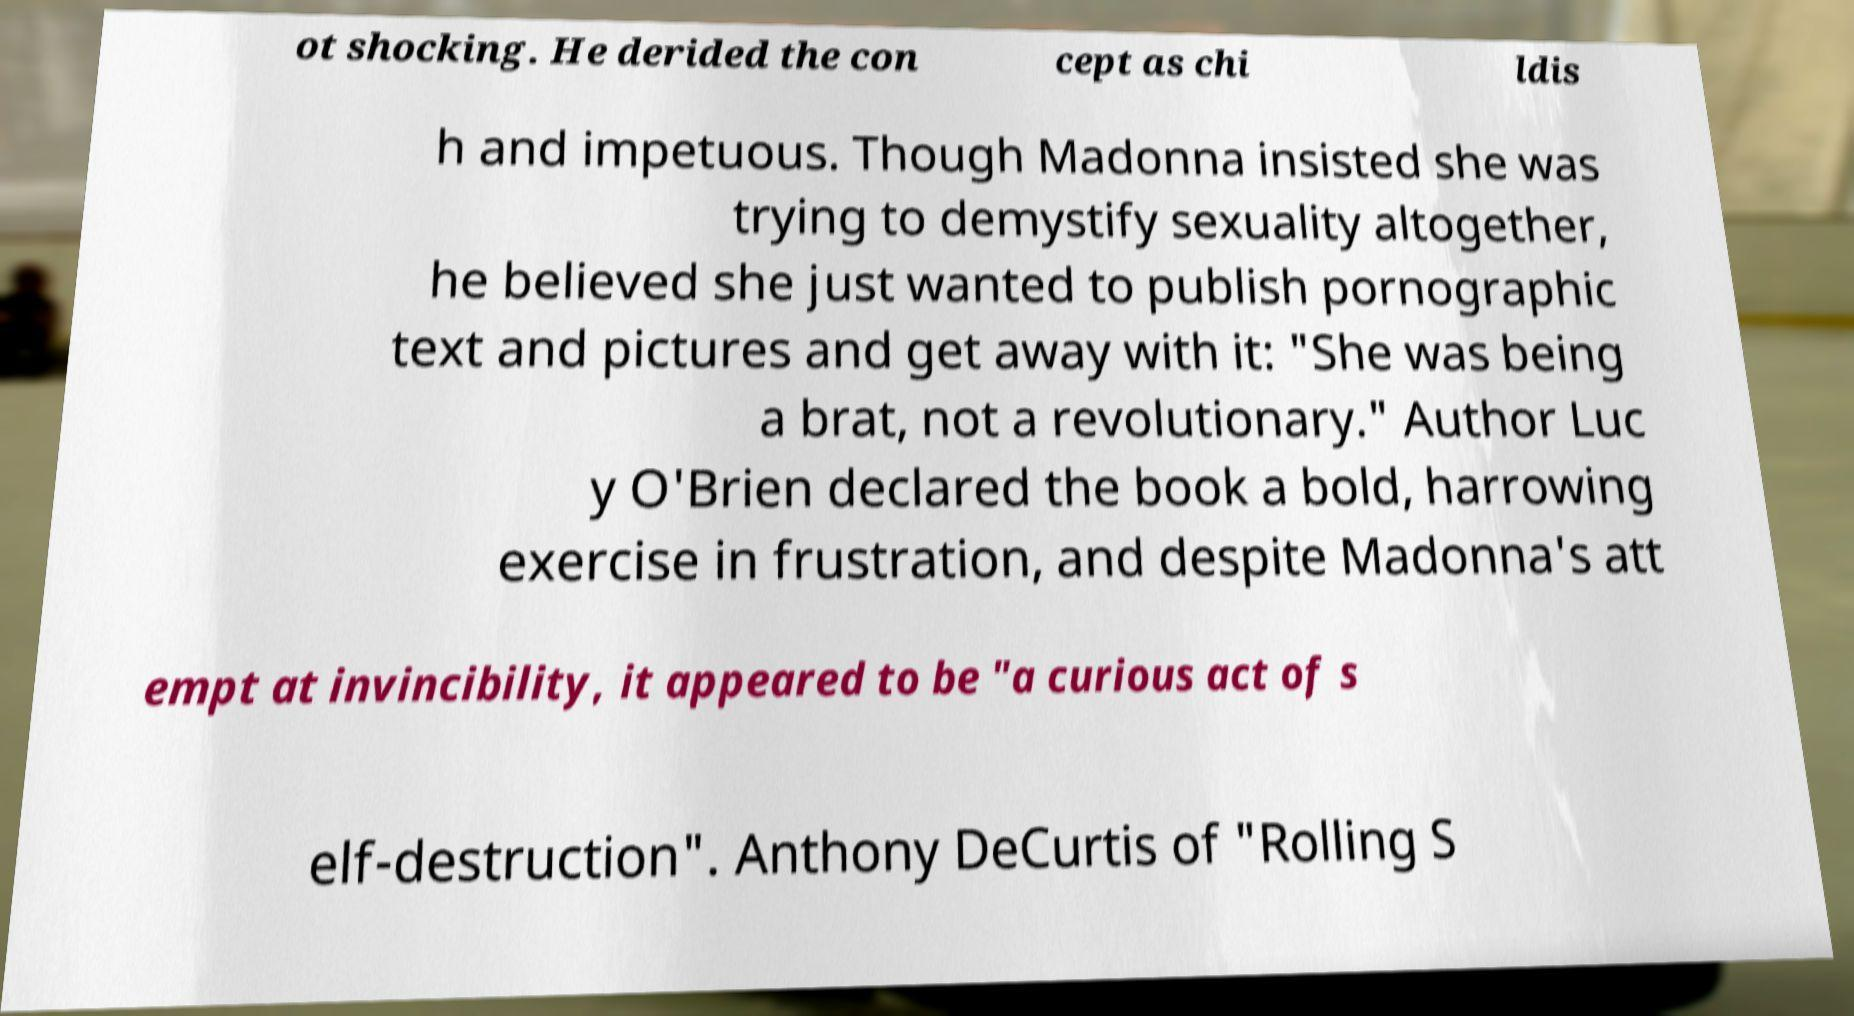I need the written content from this picture converted into text. Can you do that? ot shocking. He derided the con cept as chi ldis h and impetuous. Though Madonna insisted she was trying to demystify sexuality altogether, he believed she just wanted to publish pornographic text and pictures and get away with it: "She was being a brat, not a revolutionary." Author Luc y O'Brien declared the book a bold, harrowing exercise in frustration, and despite Madonna's att empt at invincibility, it appeared to be "a curious act of s elf-destruction". Anthony DeCurtis of "Rolling S 